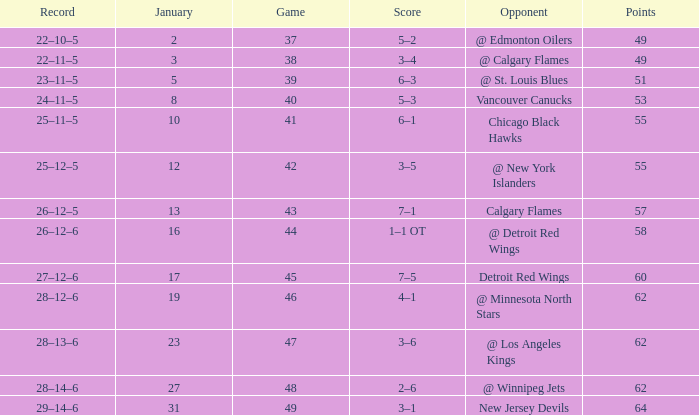Which Points have a Score of 4–1? 62.0. 